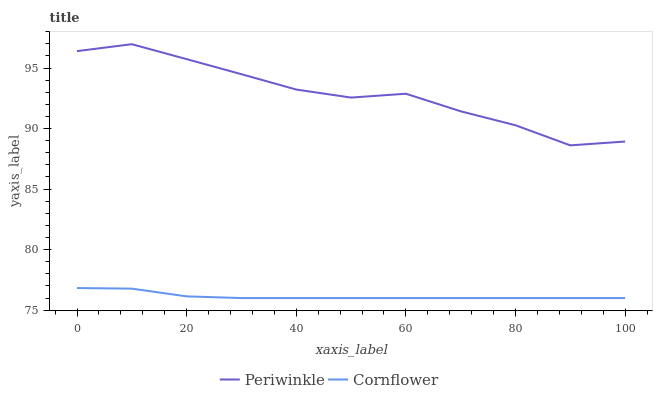Does Cornflower have the minimum area under the curve?
Answer yes or no. Yes. Does Periwinkle have the maximum area under the curve?
Answer yes or no. Yes. Does Periwinkle have the minimum area under the curve?
Answer yes or no. No. Is Cornflower the smoothest?
Answer yes or no. Yes. Is Periwinkle the roughest?
Answer yes or no. Yes. Is Periwinkle the smoothest?
Answer yes or no. No. Does Cornflower have the lowest value?
Answer yes or no. Yes. Does Periwinkle have the lowest value?
Answer yes or no. No. Does Periwinkle have the highest value?
Answer yes or no. Yes. Is Cornflower less than Periwinkle?
Answer yes or no. Yes. Is Periwinkle greater than Cornflower?
Answer yes or no. Yes. Does Cornflower intersect Periwinkle?
Answer yes or no. No. 